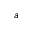<formula> <loc_0><loc_0><loc_500><loc_500>^ { a }</formula> 